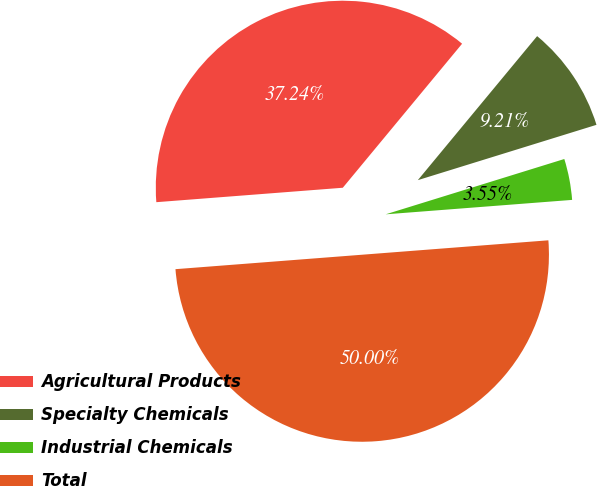<chart> <loc_0><loc_0><loc_500><loc_500><pie_chart><fcel>Agricultural Products<fcel>Specialty Chemicals<fcel>Industrial Chemicals<fcel>Total<nl><fcel>37.24%<fcel>9.21%<fcel>3.55%<fcel>50.0%<nl></chart> 